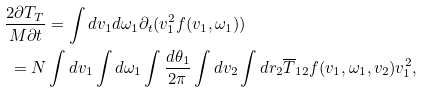Convert formula to latex. <formula><loc_0><loc_0><loc_500><loc_500>\frac { 2 \partial T _ { T } } { M \partial t } & = \int d { v } _ { 1 } d { \omega } _ { 1 } \partial _ { t } ( { v } _ { 1 } ^ { 2 } f ( { v } _ { 1 } , \omega _ { 1 } ) ) \\ = N & \int d { v } _ { 1 } \int d { \omega } _ { 1 } \int \frac { d \theta _ { 1 } } { 2 \pi } \int d { v } _ { 2 } \int d { r } _ { 2 } \overline { T } _ { 1 2 } f ( { v } _ { 1 } , \omega _ { 1 } , { v } _ { 2 } ) { v } _ { 1 } ^ { 2 } ,</formula> 